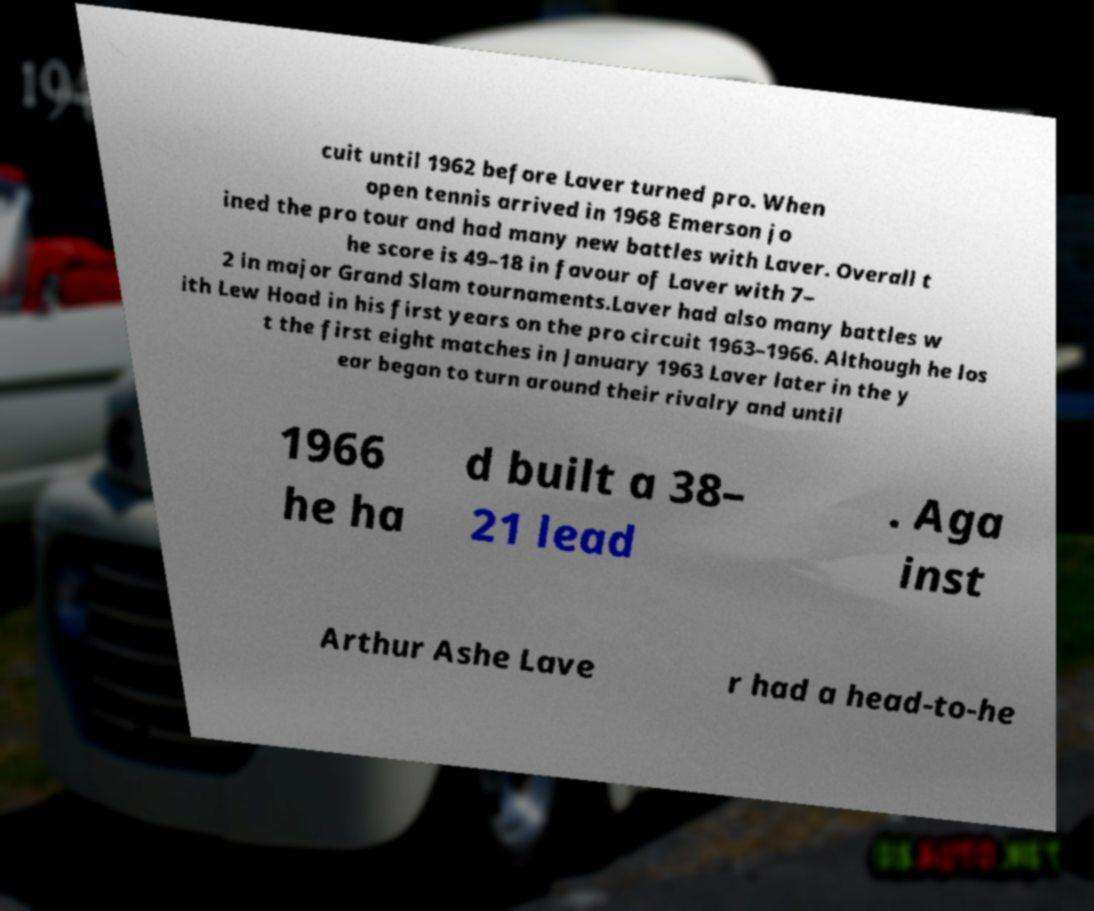I need the written content from this picture converted into text. Can you do that? cuit until 1962 before Laver turned pro. When open tennis arrived in 1968 Emerson jo ined the pro tour and had many new battles with Laver. Overall t he score is 49–18 in favour of Laver with 7– 2 in major Grand Slam tournaments.Laver had also many battles w ith Lew Hoad in his first years on the pro circuit 1963–1966. Although he los t the first eight matches in January 1963 Laver later in the y ear began to turn around their rivalry and until 1966 he ha d built a 38– 21 lead . Aga inst Arthur Ashe Lave r had a head-to-he 